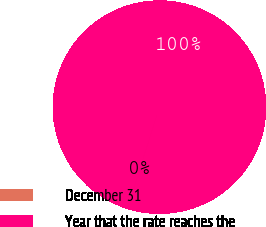<chart> <loc_0><loc_0><loc_500><loc_500><pie_chart><fcel>December 31<fcel>Year that the rate reaches the<nl><fcel>0.01%<fcel>99.99%<nl></chart> 